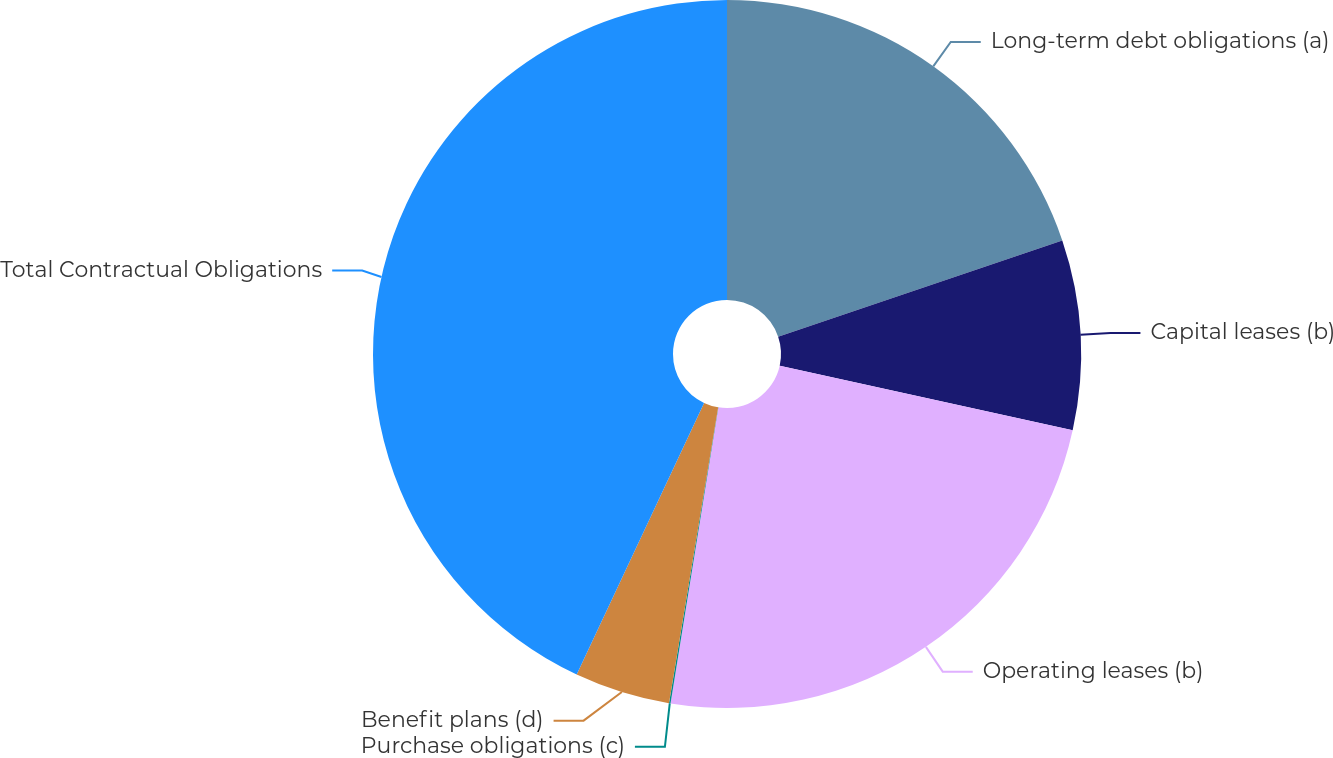<chart> <loc_0><loc_0><loc_500><loc_500><pie_chart><fcel>Long-term debt obligations (a)<fcel>Capital leases (b)<fcel>Operating leases (b)<fcel>Purchase obligations (c)<fcel>Benefit plans (d)<fcel>Total Contractual Obligations<nl><fcel>19.8%<fcel>8.66%<fcel>24.09%<fcel>0.07%<fcel>4.36%<fcel>43.02%<nl></chart> 